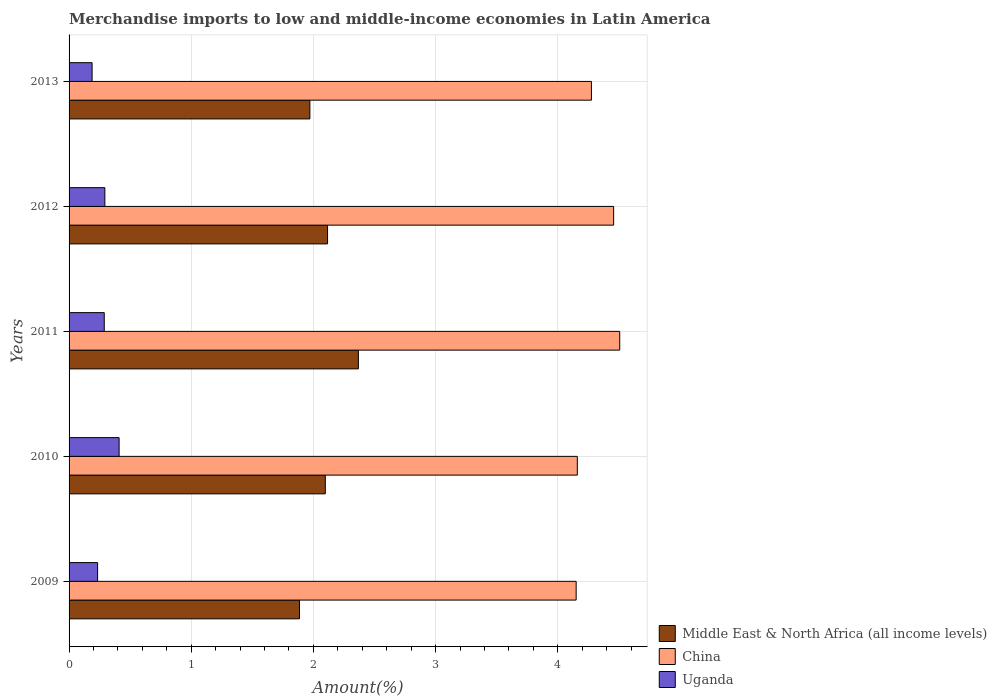How many different coloured bars are there?
Offer a very short reply. 3. How many bars are there on the 5th tick from the bottom?
Offer a very short reply. 3. In how many cases, is the number of bars for a given year not equal to the number of legend labels?
Provide a succinct answer. 0. What is the percentage of amount earned from merchandise imports in Middle East & North Africa (all income levels) in 2011?
Keep it short and to the point. 2.37. Across all years, what is the maximum percentage of amount earned from merchandise imports in Middle East & North Africa (all income levels)?
Provide a short and direct response. 2.37. Across all years, what is the minimum percentage of amount earned from merchandise imports in Uganda?
Provide a succinct answer. 0.19. In which year was the percentage of amount earned from merchandise imports in China maximum?
Provide a succinct answer. 2011. What is the total percentage of amount earned from merchandise imports in China in the graph?
Your response must be concise. 21.55. What is the difference between the percentage of amount earned from merchandise imports in Uganda in 2010 and that in 2012?
Make the answer very short. 0.12. What is the difference between the percentage of amount earned from merchandise imports in Uganda in 2010 and the percentage of amount earned from merchandise imports in China in 2011?
Your answer should be compact. -4.1. What is the average percentage of amount earned from merchandise imports in Middle East & North Africa (all income levels) per year?
Your answer should be very brief. 2.09. In the year 2009, what is the difference between the percentage of amount earned from merchandise imports in Uganda and percentage of amount earned from merchandise imports in China?
Provide a short and direct response. -3.92. In how many years, is the percentage of amount earned from merchandise imports in Middle East & North Africa (all income levels) greater than 4.2 %?
Provide a short and direct response. 0. What is the ratio of the percentage of amount earned from merchandise imports in China in 2009 to that in 2010?
Offer a terse response. 1. Is the percentage of amount earned from merchandise imports in China in 2009 less than that in 2010?
Provide a short and direct response. Yes. Is the difference between the percentage of amount earned from merchandise imports in Uganda in 2009 and 2011 greater than the difference between the percentage of amount earned from merchandise imports in China in 2009 and 2011?
Your response must be concise. Yes. What is the difference between the highest and the second highest percentage of amount earned from merchandise imports in China?
Your response must be concise. 0.05. What is the difference between the highest and the lowest percentage of amount earned from merchandise imports in China?
Provide a short and direct response. 0.36. What does the 3rd bar from the top in 2012 represents?
Offer a terse response. Middle East & North Africa (all income levels). What does the 1st bar from the bottom in 2009 represents?
Give a very brief answer. Middle East & North Africa (all income levels). How many bars are there?
Provide a succinct answer. 15. Are all the bars in the graph horizontal?
Offer a terse response. Yes. What is the difference between two consecutive major ticks on the X-axis?
Your response must be concise. 1. Are the values on the major ticks of X-axis written in scientific E-notation?
Your answer should be very brief. No. Does the graph contain grids?
Your answer should be compact. Yes. Where does the legend appear in the graph?
Your answer should be compact. Bottom right. How many legend labels are there?
Keep it short and to the point. 3. How are the legend labels stacked?
Your answer should be very brief. Vertical. What is the title of the graph?
Provide a succinct answer. Merchandise imports to low and middle-income economies in Latin America. Does "Pakistan" appear as one of the legend labels in the graph?
Give a very brief answer. No. What is the label or title of the X-axis?
Give a very brief answer. Amount(%). What is the Amount(%) in Middle East & North Africa (all income levels) in 2009?
Your response must be concise. 1.89. What is the Amount(%) of China in 2009?
Provide a succinct answer. 4.15. What is the Amount(%) in Uganda in 2009?
Ensure brevity in your answer.  0.23. What is the Amount(%) of Middle East & North Africa (all income levels) in 2010?
Give a very brief answer. 2.1. What is the Amount(%) of China in 2010?
Provide a succinct answer. 4.16. What is the Amount(%) of Uganda in 2010?
Provide a succinct answer. 0.41. What is the Amount(%) of Middle East & North Africa (all income levels) in 2011?
Your response must be concise. 2.37. What is the Amount(%) of China in 2011?
Keep it short and to the point. 4.51. What is the Amount(%) in Uganda in 2011?
Your response must be concise. 0.29. What is the Amount(%) in Middle East & North Africa (all income levels) in 2012?
Offer a terse response. 2.12. What is the Amount(%) in China in 2012?
Offer a terse response. 4.46. What is the Amount(%) of Uganda in 2012?
Provide a succinct answer. 0.29. What is the Amount(%) in Middle East & North Africa (all income levels) in 2013?
Give a very brief answer. 1.97. What is the Amount(%) of China in 2013?
Your answer should be very brief. 4.28. What is the Amount(%) of Uganda in 2013?
Offer a terse response. 0.19. Across all years, what is the maximum Amount(%) in Middle East & North Africa (all income levels)?
Keep it short and to the point. 2.37. Across all years, what is the maximum Amount(%) of China?
Your response must be concise. 4.51. Across all years, what is the maximum Amount(%) in Uganda?
Your answer should be very brief. 0.41. Across all years, what is the minimum Amount(%) of Middle East & North Africa (all income levels)?
Provide a short and direct response. 1.89. Across all years, what is the minimum Amount(%) of China?
Your answer should be compact. 4.15. Across all years, what is the minimum Amount(%) of Uganda?
Offer a very short reply. 0.19. What is the total Amount(%) in Middle East & North Africa (all income levels) in the graph?
Make the answer very short. 10.44. What is the total Amount(%) of China in the graph?
Offer a terse response. 21.55. What is the total Amount(%) of Uganda in the graph?
Keep it short and to the point. 1.41. What is the difference between the Amount(%) of Middle East & North Africa (all income levels) in 2009 and that in 2010?
Make the answer very short. -0.21. What is the difference between the Amount(%) of China in 2009 and that in 2010?
Offer a terse response. -0.01. What is the difference between the Amount(%) of Uganda in 2009 and that in 2010?
Ensure brevity in your answer.  -0.18. What is the difference between the Amount(%) of Middle East & North Africa (all income levels) in 2009 and that in 2011?
Offer a very short reply. -0.48. What is the difference between the Amount(%) in China in 2009 and that in 2011?
Provide a short and direct response. -0.36. What is the difference between the Amount(%) in Uganda in 2009 and that in 2011?
Your answer should be very brief. -0.05. What is the difference between the Amount(%) in Middle East & North Africa (all income levels) in 2009 and that in 2012?
Make the answer very short. -0.23. What is the difference between the Amount(%) of China in 2009 and that in 2012?
Provide a short and direct response. -0.31. What is the difference between the Amount(%) of Uganda in 2009 and that in 2012?
Provide a succinct answer. -0.06. What is the difference between the Amount(%) in Middle East & North Africa (all income levels) in 2009 and that in 2013?
Ensure brevity in your answer.  -0.09. What is the difference between the Amount(%) of China in 2009 and that in 2013?
Offer a very short reply. -0.12. What is the difference between the Amount(%) in Uganda in 2009 and that in 2013?
Make the answer very short. 0.04. What is the difference between the Amount(%) of Middle East & North Africa (all income levels) in 2010 and that in 2011?
Keep it short and to the point. -0.27. What is the difference between the Amount(%) of China in 2010 and that in 2011?
Make the answer very short. -0.35. What is the difference between the Amount(%) in Uganda in 2010 and that in 2011?
Provide a short and direct response. 0.12. What is the difference between the Amount(%) in Middle East & North Africa (all income levels) in 2010 and that in 2012?
Provide a succinct answer. -0.02. What is the difference between the Amount(%) of China in 2010 and that in 2012?
Your answer should be very brief. -0.3. What is the difference between the Amount(%) of Uganda in 2010 and that in 2012?
Make the answer very short. 0.12. What is the difference between the Amount(%) in Middle East & North Africa (all income levels) in 2010 and that in 2013?
Provide a short and direct response. 0.13. What is the difference between the Amount(%) of China in 2010 and that in 2013?
Provide a short and direct response. -0.12. What is the difference between the Amount(%) of Uganda in 2010 and that in 2013?
Your response must be concise. 0.22. What is the difference between the Amount(%) of Middle East & North Africa (all income levels) in 2011 and that in 2012?
Keep it short and to the point. 0.25. What is the difference between the Amount(%) of China in 2011 and that in 2012?
Make the answer very short. 0.05. What is the difference between the Amount(%) in Uganda in 2011 and that in 2012?
Offer a terse response. -0. What is the difference between the Amount(%) of Middle East & North Africa (all income levels) in 2011 and that in 2013?
Provide a succinct answer. 0.4. What is the difference between the Amount(%) in China in 2011 and that in 2013?
Make the answer very short. 0.23. What is the difference between the Amount(%) in Uganda in 2011 and that in 2013?
Provide a succinct answer. 0.1. What is the difference between the Amount(%) of Middle East & North Africa (all income levels) in 2012 and that in 2013?
Offer a terse response. 0.14. What is the difference between the Amount(%) in China in 2012 and that in 2013?
Keep it short and to the point. 0.18. What is the difference between the Amount(%) of Uganda in 2012 and that in 2013?
Give a very brief answer. 0.1. What is the difference between the Amount(%) of Middle East & North Africa (all income levels) in 2009 and the Amount(%) of China in 2010?
Offer a terse response. -2.27. What is the difference between the Amount(%) of Middle East & North Africa (all income levels) in 2009 and the Amount(%) of Uganda in 2010?
Provide a succinct answer. 1.48. What is the difference between the Amount(%) of China in 2009 and the Amount(%) of Uganda in 2010?
Your answer should be compact. 3.74. What is the difference between the Amount(%) of Middle East & North Africa (all income levels) in 2009 and the Amount(%) of China in 2011?
Offer a very short reply. -2.62. What is the difference between the Amount(%) of Middle East & North Africa (all income levels) in 2009 and the Amount(%) of Uganda in 2011?
Keep it short and to the point. 1.6. What is the difference between the Amount(%) of China in 2009 and the Amount(%) of Uganda in 2011?
Give a very brief answer. 3.86. What is the difference between the Amount(%) of Middle East & North Africa (all income levels) in 2009 and the Amount(%) of China in 2012?
Give a very brief answer. -2.57. What is the difference between the Amount(%) in Middle East & North Africa (all income levels) in 2009 and the Amount(%) in Uganda in 2012?
Give a very brief answer. 1.59. What is the difference between the Amount(%) of China in 2009 and the Amount(%) of Uganda in 2012?
Give a very brief answer. 3.86. What is the difference between the Amount(%) of Middle East & North Africa (all income levels) in 2009 and the Amount(%) of China in 2013?
Keep it short and to the point. -2.39. What is the difference between the Amount(%) in Middle East & North Africa (all income levels) in 2009 and the Amount(%) in Uganda in 2013?
Provide a short and direct response. 1.7. What is the difference between the Amount(%) in China in 2009 and the Amount(%) in Uganda in 2013?
Your answer should be compact. 3.96. What is the difference between the Amount(%) in Middle East & North Africa (all income levels) in 2010 and the Amount(%) in China in 2011?
Ensure brevity in your answer.  -2.41. What is the difference between the Amount(%) of Middle East & North Africa (all income levels) in 2010 and the Amount(%) of Uganda in 2011?
Your response must be concise. 1.81. What is the difference between the Amount(%) of China in 2010 and the Amount(%) of Uganda in 2011?
Provide a succinct answer. 3.87. What is the difference between the Amount(%) of Middle East & North Africa (all income levels) in 2010 and the Amount(%) of China in 2012?
Make the answer very short. -2.36. What is the difference between the Amount(%) of Middle East & North Africa (all income levels) in 2010 and the Amount(%) of Uganda in 2012?
Offer a terse response. 1.8. What is the difference between the Amount(%) in China in 2010 and the Amount(%) in Uganda in 2012?
Provide a succinct answer. 3.87. What is the difference between the Amount(%) in Middle East & North Africa (all income levels) in 2010 and the Amount(%) in China in 2013?
Provide a short and direct response. -2.18. What is the difference between the Amount(%) of Middle East & North Africa (all income levels) in 2010 and the Amount(%) of Uganda in 2013?
Your answer should be very brief. 1.91. What is the difference between the Amount(%) of China in 2010 and the Amount(%) of Uganda in 2013?
Make the answer very short. 3.97. What is the difference between the Amount(%) in Middle East & North Africa (all income levels) in 2011 and the Amount(%) in China in 2012?
Offer a terse response. -2.09. What is the difference between the Amount(%) in Middle East & North Africa (all income levels) in 2011 and the Amount(%) in Uganda in 2012?
Your answer should be compact. 2.08. What is the difference between the Amount(%) of China in 2011 and the Amount(%) of Uganda in 2012?
Offer a very short reply. 4.21. What is the difference between the Amount(%) of Middle East & North Africa (all income levels) in 2011 and the Amount(%) of China in 2013?
Make the answer very short. -1.91. What is the difference between the Amount(%) of Middle East & North Africa (all income levels) in 2011 and the Amount(%) of Uganda in 2013?
Make the answer very short. 2.18. What is the difference between the Amount(%) in China in 2011 and the Amount(%) in Uganda in 2013?
Provide a succinct answer. 4.32. What is the difference between the Amount(%) in Middle East & North Africa (all income levels) in 2012 and the Amount(%) in China in 2013?
Keep it short and to the point. -2.16. What is the difference between the Amount(%) in Middle East & North Africa (all income levels) in 2012 and the Amount(%) in Uganda in 2013?
Your answer should be very brief. 1.93. What is the difference between the Amount(%) of China in 2012 and the Amount(%) of Uganda in 2013?
Your answer should be compact. 4.27. What is the average Amount(%) in Middle East & North Africa (all income levels) per year?
Provide a short and direct response. 2.09. What is the average Amount(%) of China per year?
Offer a very short reply. 4.31. What is the average Amount(%) in Uganda per year?
Your answer should be compact. 0.28. In the year 2009, what is the difference between the Amount(%) of Middle East & North Africa (all income levels) and Amount(%) of China?
Offer a terse response. -2.26. In the year 2009, what is the difference between the Amount(%) of Middle East & North Africa (all income levels) and Amount(%) of Uganda?
Your response must be concise. 1.65. In the year 2009, what is the difference between the Amount(%) in China and Amount(%) in Uganda?
Make the answer very short. 3.92. In the year 2010, what is the difference between the Amount(%) in Middle East & North Africa (all income levels) and Amount(%) in China?
Make the answer very short. -2.06. In the year 2010, what is the difference between the Amount(%) in Middle East & North Africa (all income levels) and Amount(%) in Uganda?
Your answer should be compact. 1.69. In the year 2010, what is the difference between the Amount(%) in China and Amount(%) in Uganda?
Offer a very short reply. 3.75. In the year 2011, what is the difference between the Amount(%) in Middle East & North Africa (all income levels) and Amount(%) in China?
Give a very brief answer. -2.14. In the year 2011, what is the difference between the Amount(%) in Middle East & North Africa (all income levels) and Amount(%) in Uganda?
Offer a terse response. 2.08. In the year 2011, what is the difference between the Amount(%) of China and Amount(%) of Uganda?
Offer a very short reply. 4.22. In the year 2012, what is the difference between the Amount(%) in Middle East & North Africa (all income levels) and Amount(%) in China?
Your answer should be compact. -2.34. In the year 2012, what is the difference between the Amount(%) of Middle East & North Africa (all income levels) and Amount(%) of Uganda?
Make the answer very short. 1.82. In the year 2012, what is the difference between the Amount(%) in China and Amount(%) in Uganda?
Your response must be concise. 4.16. In the year 2013, what is the difference between the Amount(%) in Middle East & North Africa (all income levels) and Amount(%) in China?
Your answer should be very brief. -2.3. In the year 2013, what is the difference between the Amount(%) of Middle East & North Africa (all income levels) and Amount(%) of Uganda?
Keep it short and to the point. 1.78. In the year 2013, what is the difference between the Amount(%) in China and Amount(%) in Uganda?
Offer a very short reply. 4.09. What is the ratio of the Amount(%) in Middle East & North Africa (all income levels) in 2009 to that in 2010?
Ensure brevity in your answer.  0.9. What is the ratio of the Amount(%) of China in 2009 to that in 2010?
Your answer should be compact. 1. What is the ratio of the Amount(%) of Uganda in 2009 to that in 2010?
Your answer should be compact. 0.57. What is the ratio of the Amount(%) in Middle East & North Africa (all income levels) in 2009 to that in 2011?
Provide a short and direct response. 0.8. What is the ratio of the Amount(%) in China in 2009 to that in 2011?
Your answer should be compact. 0.92. What is the ratio of the Amount(%) of Uganda in 2009 to that in 2011?
Give a very brief answer. 0.81. What is the ratio of the Amount(%) in Middle East & North Africa (all income levels) in 2009 to that in 2012?
Your answer should be very brief. 0.89. What is the ratio of the Amount(%) in China in 2009 to that in 2012?
Make the answer very short. 0.93. What is the ratio of the Amount(%) in Uganda in 2009 to that in 2012?
Offer a very short reply. 0.8. What is the ratio of the Amount(%) of Middle East & North Africa (all income levels) in 2009 to that in 2013?
Keep it short and to the point. 0.96. What is the ratio of the Amount(%) in China in 2009 to that in 2013?
Provide a short and direct response. 0.97. What is the ratio of the Amount(%) of Uganda in 2009 to that in 2013?
Make the answer very short. 1.24. What is the ratio of the Amount(%) in Middle East & North Africa (all income levels) in 2010 to that in 2011?
Your answer should be very brief. 0.89. What is the ratio of the Amount(%) in China in 2010 to that in 2011?
Keep it short and to the point. 0.92. What is the ratio of the Amount(%) of Uganda in 2010 to that in 2011?
Your answer should be very brief. 1.42. What is the ratio of the Amount(%) in Uganda in 2010 to that in 2012?
Provide a short and direct response. 1.4. What is the ratio of the Amount(%) of Middle East & North Africa (all income levels) in 2010 to that in 2013?
Offer a terse response. 1.06. What is the ratio of the Amount(%) in Uganda in 2010 to that in 2013?
Offer a very short reply. 2.17. What is the ratio of the Amount(%) in Middle East & North Africa (all income levels) in 2011 to that in 2012?
Your response must be concise. 1.12. What is the ratio of the Amount(%) in China in 2011 to that in 2012?
Offer a terse response. 1.01. What is the ratio of the Amount(%) of Uganda in 2011 to that in 2012?
Provide a succinct answer. 0.98. What is the ratio of the Amount(%) in Middle East & North Africa (all income levels) in 2011 to that in 2013?
Offer a very short reply. 1.2. What is the ratio of the Amount(%) in China in 2011 to that in 2013?
Ensure brevity in your answer.  1.05. What is the ratio of the Amount(%) of Uganda in 2011 to that in 2013?
Provide a short and direct response. 1.53. What is the ratio of the Amount(%) of Middle East & North Africa (all income levels) in 2012 to that in 2013?
Offer a terse response. 1.07. What is the ratio of the Amount(%) in China in 2012 to that in 2013?
Your response must be concise. 1.04. What is the ratio of the Amount(%) of Uganda in 2012 to that in 2013?
Give a very brief answer. 1.55. What is the difference between the highest and the second highest Amount(%) in Middle East & North Africa (all income levels)?
Your answer should be compact. 0.25. What is the difference between the highest and the second highest Amount(%) in China?
Ensure brevity in your answer.  0.05. What is the difference between the highest and the second highest Amount(%) of Uganda?
Offer a very short reply. 0.12. What is the difference between the highest and the lowest Amount(%) in Middle East & North Africa (all income levels)?
Provide a succinct answer. 0.48. What is the difference between the highest and the lowest Amount(%) of China?
Provide a short and direct response. 0.36. What is the difference between the highest and the lowest Amount(%) of Uganda?
Keep it short and to the point. 0.22. 